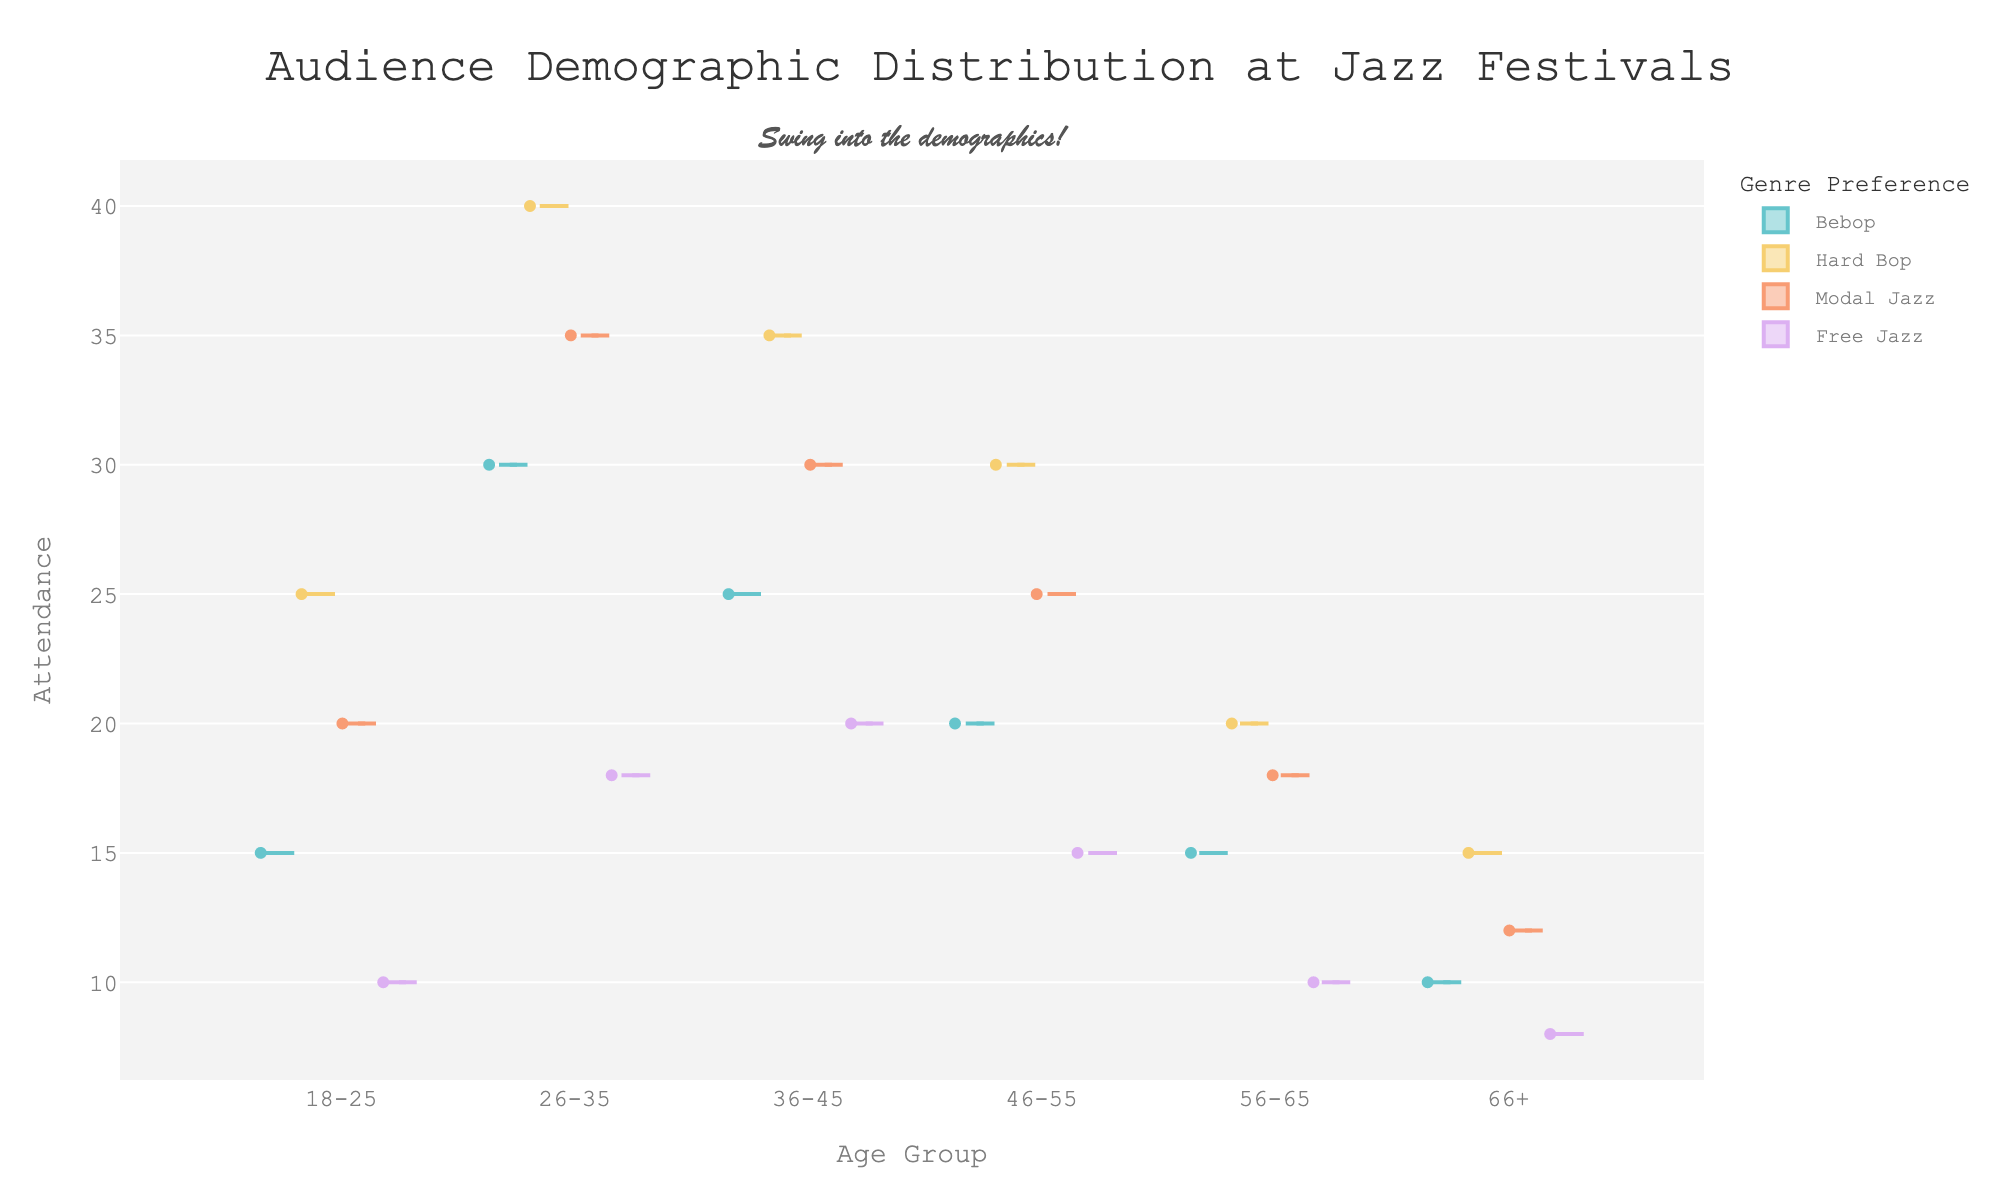What is the title of the plot? The title is located at the top center of the plot and in a larger font size. It clearly states the subject of the visualization.
Answer: Audience Demographic Distribution at Jazz Festivals Which age group has the highest attendance for Hard Bop? By observing the height of the distribution for each age group under the "Hard Bop" color, we can identify the age group with the highest attendance.
Answer: 26-35 What is the median attendance for the 46-55 age group across all genres? Each box plot within the violin plot indicates the median with a horizontal line inside the box. By checking the 46-55 age group, we sum up the median values for Bebop, Hard Bop, Modal Jazz, and Free Jazz, then divide by 4.
Answer: (20 + 30 + 25 + 15) / 4 = 22.5 How does the distribution of attendance for Modal Jazz compare between the 18-25 and 36-45 age groups? Compare the spread and median lines of the "Modal Jazz" segments for these two age groups to see which has higher and more variable attendance.
Answer: 36-45 has a higher median (30 vs. 20) and a slightly wider distribution Which genre has the least attendance in the 66+ age group? By looking at the height and spread of the violins for each genre within the 66+ age category, the lowest distribution indicates the least attendance.
Answer: Free Jazz Is there more variance in attendance for Free Jazz or Bebop across all age groups? By comparing the width of the violin plots for "Free Jazz" and "Bebop," we can see which distribution spreads out more, indicating greater variance.
Answer: Bebop What is the average attendance for the 18-25 age group across all genres? Sum the attendance values for Bebop, Hard Bop, Modal Jazz, and Free Jazz in the 18-25 age group, then divide by 4.
Answer: (15 + 25 + 20 + 10) / 4 = 17.5 Does the 26-35 age group prefer Bebop or Free Jazz more? Compare the height and distribution spread of the "Bebop" and "Free Jazz" violins for the 26-35 age group. The one with the higher median and larger width indicates preference.
Answer: Bebop (median 30 vs. 18) Which age group has the smallest interquartile range (IQR) for Hard Bop? The IQR is represented by the height of the box in the box plot. The age group with the shortest box for "Hard Bop" has the smallest IQR.
Answer: 66+ Across all genres, which age group shows the widest distribution in attendance? The age group with the widest violin plot (largest spread from top to bottom) across all colors has the widest distribution.
Answer: 26-35 